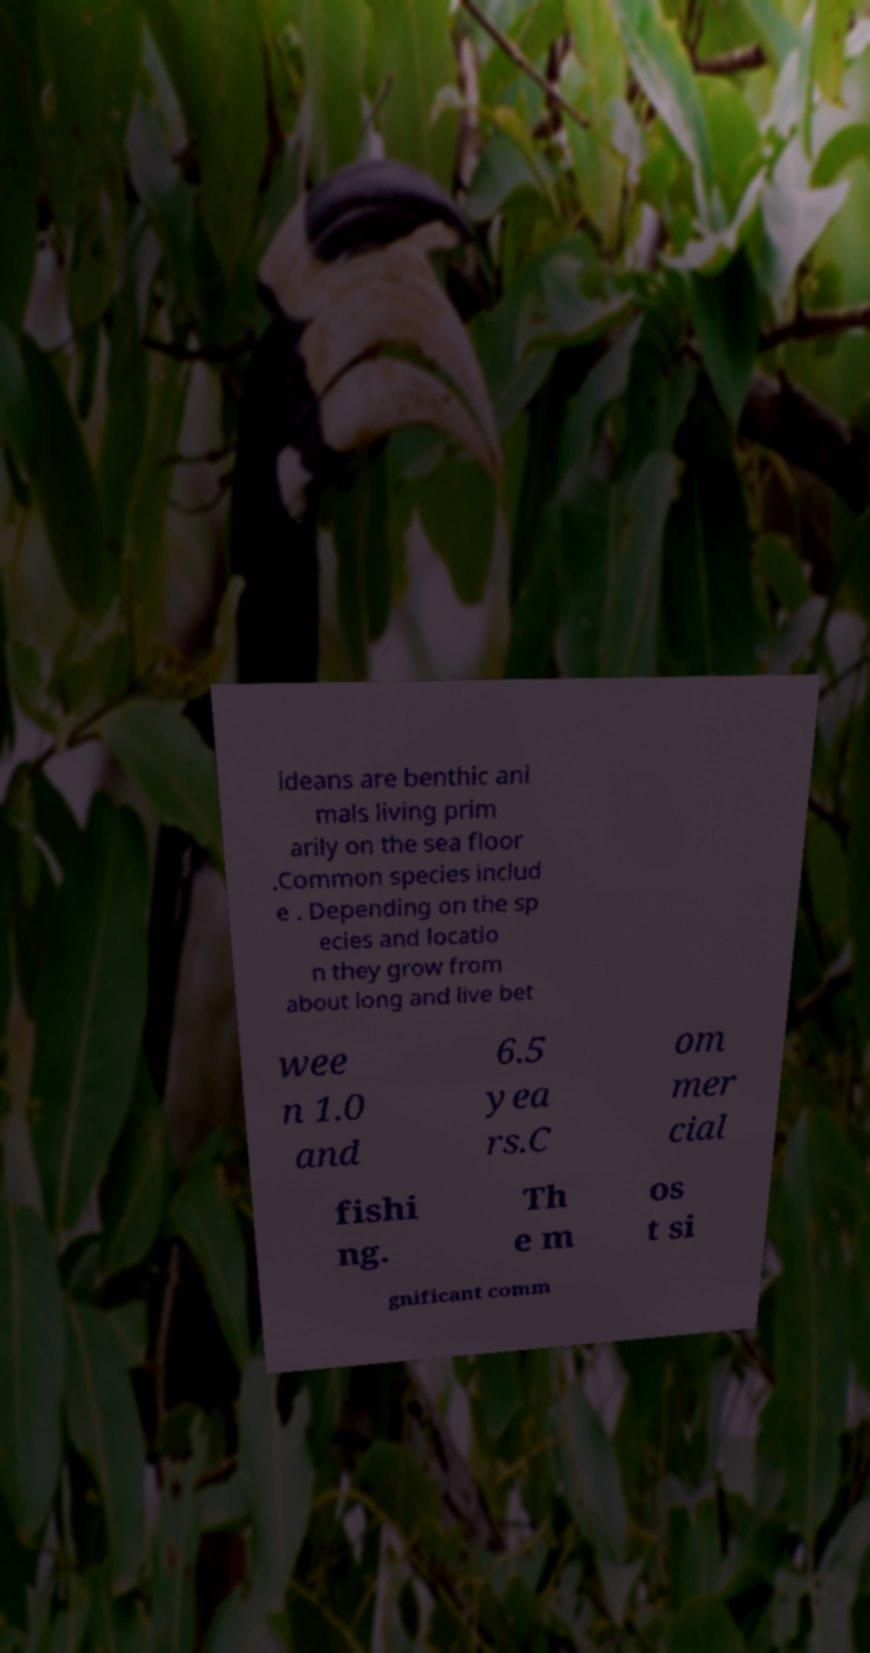Can you accurately transcribe the text from the provided image for me? ideans are benthic ani mals living prim arily on the sea floor .Common species includ e . Depending on the sp ecies and locatio n they grow from about long and live bet wee n 1.0 and 6.5 yea rs.C om mer cial fishi ng. Th e m os t si gnificant comm 